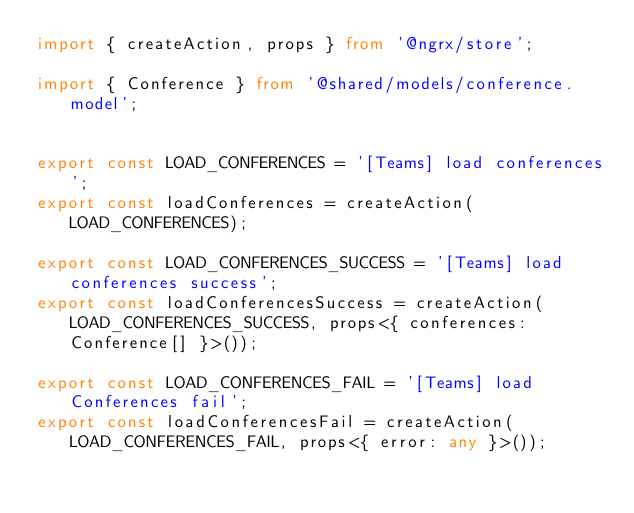Convert code to text. <code><loc_0><loc_0><loc_500><loc_500><_TypeScript_>import { createAction, props } from '@ngrx/store';

import { Conference } from '@shared/models/conference.model';


export const LOAD_CONFERENCES = '[Teams] load conferences';
export const loadConferences = createAction(LOAD_CONFERENCES);

export const LOAD_CONFERENCES_SUCCESS = '[Teams] load conferences success';
export const loadConferencesSuccess = createAction(LOAD_CONFERENCES_SUCCESS, props<{ conferences: Conference[] }>());

export const LOAD_CONFERENCES_FAIL = '[Teams] load Conferences fail';
export const loadConferencesFail = createAction(LOAD_CONFERENCES_FAIL, props<{ error: any }>());
</code> 